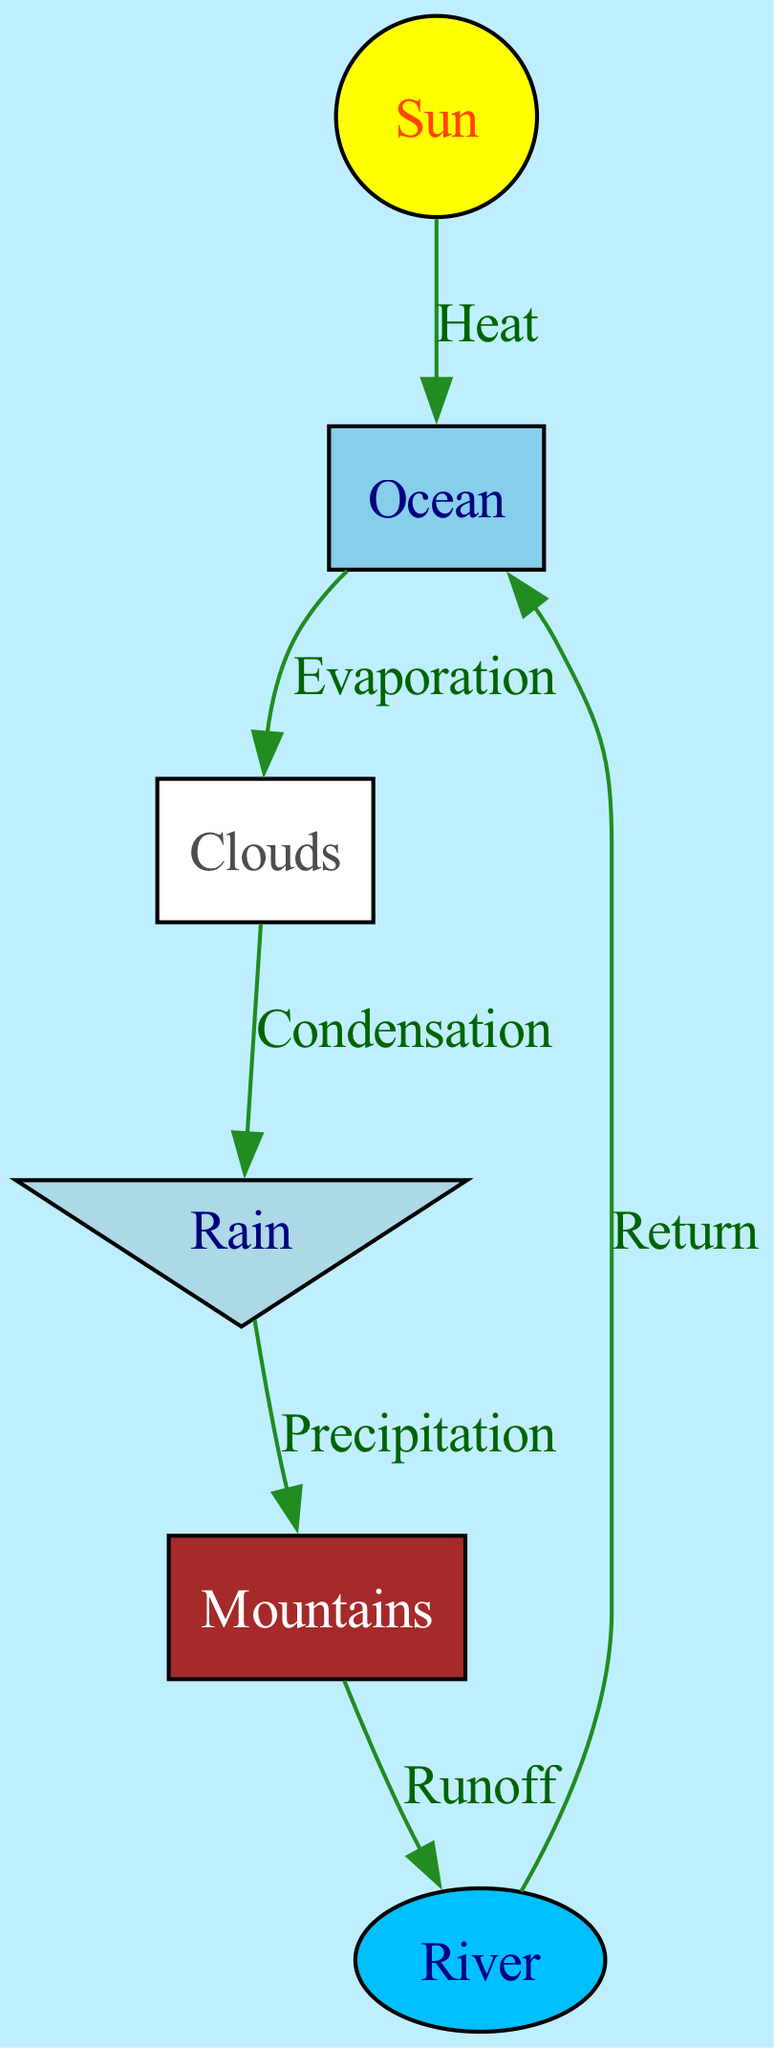What are the main processes illustrated in this diagram? The diagram illustrates evaporation, condensation, and precipitation, as indicated by the labels on the edges connecting the nodes. Each process is represented by a specific flow from one node to another.
Answer: Evaporation, condensation, precipitation How many nodes are present in the diagram? By counting the distinct labeled elements representing different components of the water cycle, we identify six nodes: Ocean, Sun, Clouds, Rain, Mountains, and River.
Answer: 6 What connects the Ocean to the Clouds? The connection between the Ocean and the Clouds is labeled as "Evaporation," which indicates how water from the ocean is transformed into vapor and rises into the atmosphere.
Answer: Evaporation What is the outcome of Rain in the diagram? According to the flow represented in the diagram, Rain leads to Mountains through the process labeled "Precipitation." This indicates that rain falls onto the mountains.
Answer: Precipitation What is the relationship between Clouds and Rain? The diagram shows an edge labeled "Condensation" between Clouds and Rain, indicating that clouds condense to form rain.
Answer: Condensation Which component receives runoff from the Mountains? The flow indicates that the Mountains contribute runoff to the River, as represented by the direct connection labeled "Runoff."
Answer: River What natural element drives the initial process of evaporation? The Sun drives the initial process of evaporation as depicted by the edge labeled "Heat" connecting the Sun to the Ocean, indicating that the sun provides energy for evaporation to occur.
Answer: Sun How does water return to the Ocean from the River? The connection from the River back to the Ocean is labeled "Return," illustrating the process of water flowing back to the ocean after traveling through the river.
Answer: Return 